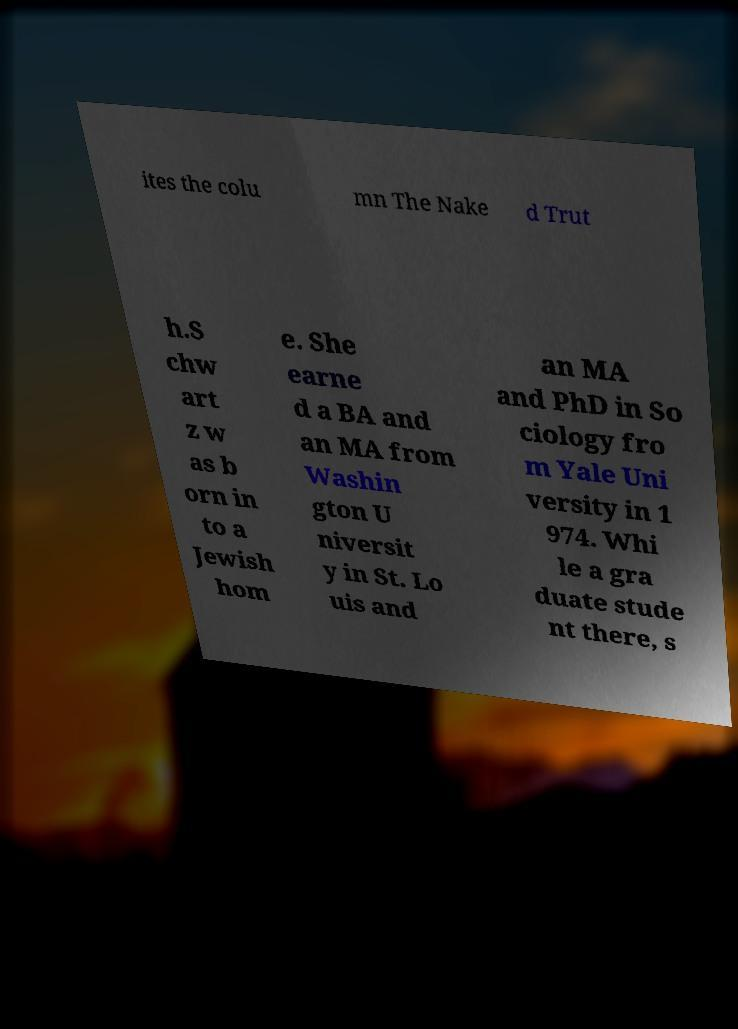Can you accurately transcribe the text from the provided image for me? ites the colu mn The Nake d Trut h.S chw art z w as b orn in to a Jewish hom e. She earne d a BA and an MA from Washin gton U niversit y in St. Lo uis and an MA and PhD in So ciology fro m Yale Uni versity in 1 974. Whi le a gra duate stude nt there, s 